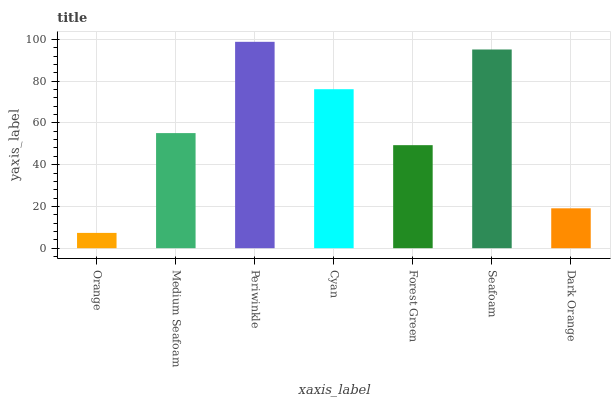Is Orange the minimum?
Answer yes or no. Yes. Is Periwinkle the maximum?
Answer yes or no. Yes. Is Medium Seafoam the minimum?
Answer yes or no. No. Is Medium Seafoam the maximum?
Answer yes or no. No. Is Medium Seafoam greater than Orange?
Answer yes or no. Yes. Is Orange less than Medium Seafoam?
Answer yes or no. Yes. Is Orange greater than Medium Seafoam?
Answer yes or no. No. Is Medium Seafoam less than Orange?
Answer yes or no. No. Is Medium Seafoam the high median?
Answer yes or no. Yes. Is Medium Seafoam the low median?
Answer yes or no. Yes. Is Periwinkle the high median?
Answer yes or no. No. Is Seafoam the low median?
Answer yes or no. No. 